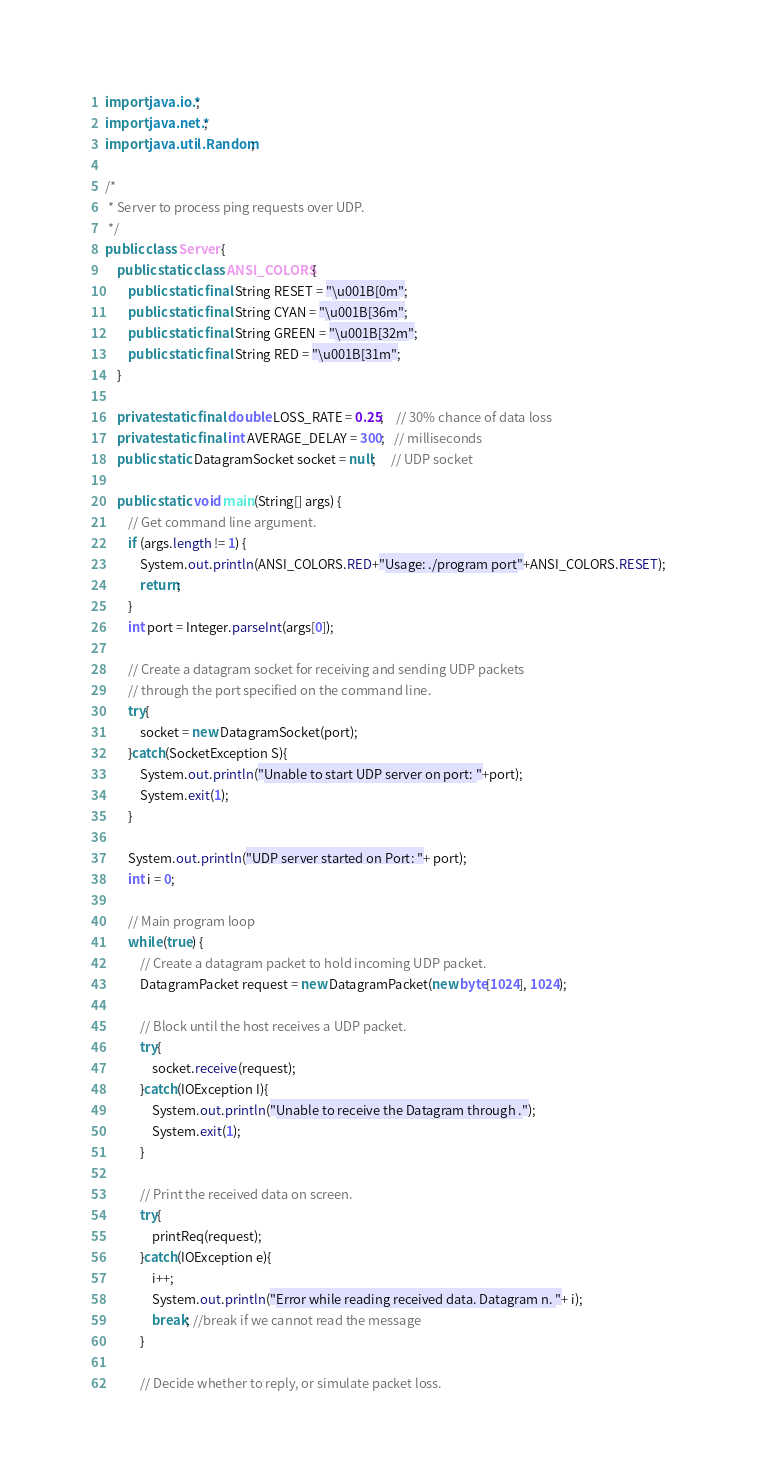Convert code to text. <code><loc_0><loc_0><loc_500><loc_500><_Java_>import java.io.*;
import java.net.*;
import java.util.Random;

/*
 * Server to process ping requests over UDP.
 */
public class Server {
    public static class ANSI_COLORS{
        public static final String RESET = "\u001B[0m";
        public static final String CYAN = "\u001B[36m";
        public static final String GREEN = "\u001B[32m";
        public static final String RED = "\u001B[31m";
    }

    private static final double LOSS_RATE = 0.25;    // 30% chance of data loss
    private static final int AVERAGE_DELAY = 300;   // milliseconds
    public static DatagramSocket socket = null;     // UDP socket

    public static void main(String[] args) {
        // Get command line argument.
        if (args.length != 1) {
            System.out.println(ANSI_COLORS.RED+"Usage: ./program port"+ANSI_COLORS.RESET);
            return;
        }
        int port = Integer.parseInt(args[0]);

        // Create a datagram socket for receiving and sending UDP packets
        // through the port specified on the command line.
        try{
            socket = new DatagramSocket(port);
        }catch(SocketException S){
            System.out.println("Unable to start UDP server on port: "+port);
            System.exit(1);
        }

        System.out.println("UDP server started on Port: "+ port);
        int i = 0;

        // Main program loop
        while (true) {
            // Create a datagram packet to hold incoming UDP packet.
            DatagramPacket request = new DatagramPacket(new byte[1024], 1024);

            // Block until the host receives a UDP packet.
            try{
                socket.receive(request);
            }catch(IOException I){
                System.out.println("Unable to receive the Datagram through .");
                System.exit(1);
            }

            // Print the received data on screen.
            try{
                printReq(request);
            }catch(IOException e){
                i++;
                System.out.println("Error while reading received data. Datagram n. "+ i);
                break; //break if we cannot read the message
            }

            // Decide whether to reply, or simulate packet loss.</code> 